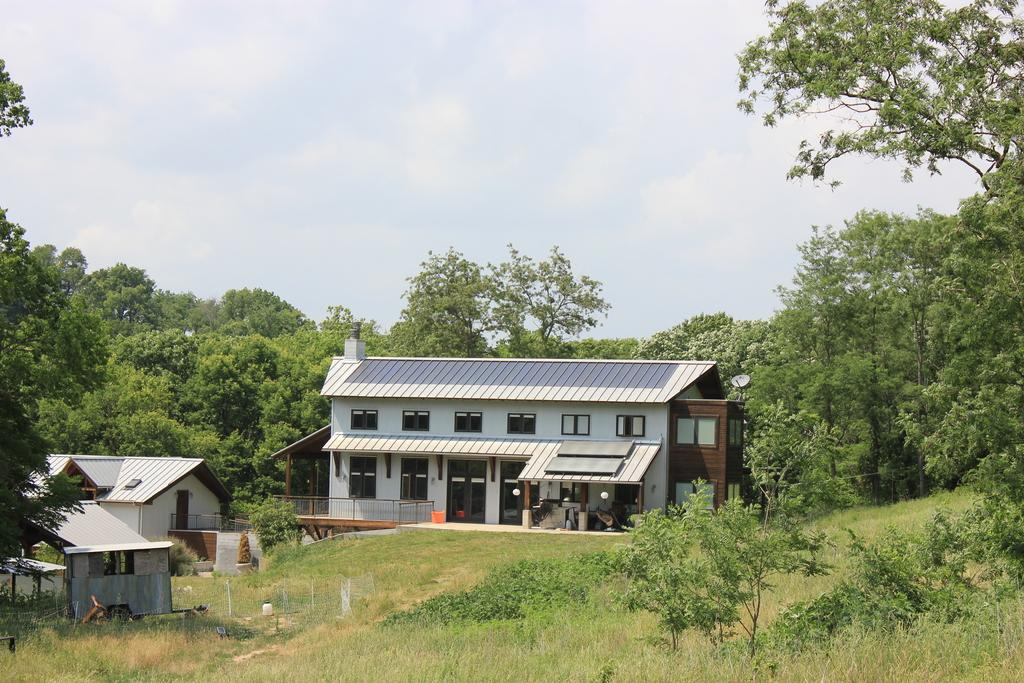How many buildings are visible in the image? There are two buildings in the image. What is the ground like in front of the buildings? The ground in front of the buildings is green. Can you describe any other objects or features in the image? There is a part of a vehicle in the left corner of the image, and there are trees in the background. What type of popcorn is being served at the event happening in the image? There is no event or popcorn present in the image; it features two buildings, a green ground, a vehicle part, and trees in the background. 